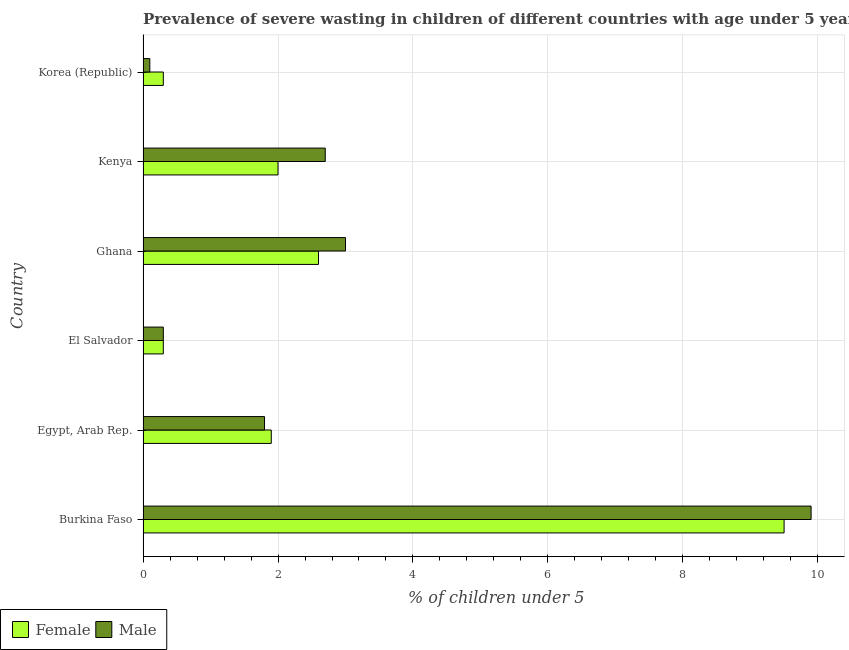How many different coloured bars are there?
Keep it short and to the point. 2. Are the number of bars per tick equal to the number of legend labels?
Your response must be concise. Yes. Are the number of bars on each tick of the Y-axis equal?
Provide a short and direct response. Yes. Across all countries, what is the maximum percentage of undernourished male children?
Give a very brief answer. 9.9. Across all countries, what is the minimum percentage of undernourished female children?
Keep it short and to the point. 0.3. In which country was the percentage of undernourished female children maximum?
Your answer should be compact. Burkina Faso. In which country was the percentage of undernourished male children minimum?
Your answer should be compact. Korea (Republic). What is the total percentage of undernourished male children in the graph?
Ensure brevity in your answer.  17.8. What is the difference between the percentage of undernourished male children in Kenya and the percentage of undernourished female children in Korea (Republic)?
Make the answer very short. 2.4. What is the average percentage of undernourished male children per country?
Your response must be concise. 2.97. What is the difference between the percentage of undernourished female children and percentage of undernourished male children in Kenya?
Ensure brevity in your answer.  -0.7. What is the difference between the highest and the lowest percentage of undernourished female children?
Your response must be concise. 9.2. In how many countries, is the percentage of undernourished female children greater than the average percentage of undernourished female children taken over all countries?
Provide a succinct answer. 1. Is the sum of the percentage of undernourished male children in Egypt, Arab Rep. and Kenya greater than the maximum percentage of undernourished female children across all countries?
Your answer should be compact. No. What does the 2nd bar from the top in Korea (Republic) represents?
Ensure brevity in your answer.  Female. What does the 1st bar from the bottom in Egypt, Arab Rep. represents?
Your answer should be compact. Female. How many bars are there?
Your answer should be very brief. 12. Are all the bars in the graph horizontal?
Provide a short and direct response. Yes. What is the difference between two consecutive major ticks on the X-axis?
Keep it short and to the point. 2. Does the graph contain any zero values?
Give a very brief answer. No. Where does the legend appear in the graph?
Your answer should be very brief. Bottom left. How many legend labels are there?
Make the answer very short. 2. What is the title of the graph?
Offer a very short reply. Prevalence of severe wasting in children of different countries with age under 5 years. What is the label or title of the X-axis?
Your answer should be compact.  % of children under 5. What is the  % of children under 5 of Male in Burkina Faso?
Provide a short and direct response. 9.9. What is the  % of children under 5 in Female in Egypt, Arab Rep.?
Keep it short and to the point. 1.9. What is the  % of children under 5 in Male in Egypt, Arab Rep.?
Ensure brevity in your answer.  1.8. What is the  % of children under 5 of Female in El Salvador?
Provide a succinct answer. 0.3. What is the  % of children under 5 in Male in El Salvador?
Ensure brevity in your answer.  0.3. What is the  % of children under 5 of Female in Ghana?
Make the answer very short. 2.6. What is the  % of children under 5 in Male in Kenya?
Offer a terse response. 2.7. What is the  % of children under 5 in Female in Korea (Republic)?
Your answer should be very brief. 0.3. What is the  % of children under 5 of Male in Korea (Republic)?
Give a very brief answer. 0.1. Across all countries, what is the maximum  % of children under 5 in Male?
Ensure brevity in your answer.  9.9. Across all countries, what is the minimum  % of children under 5 of Female?
Offer a very short reply. 0.3. Across all countries, what is the minimum  % of children under 5 of Male?
Your answer should be compact. 0.1. What is the total  % of children under 5 in Male in the graph?
Offer a terse response. 17.8. What is the difference between the  % of children under 5 in Female in Burkina Faso and that in Egypt, Arab Rep.?
Ensure brevity in your answer.  7.6. What is the difference between the  % of children under 5 in Male in Burkina Faso and that in Egypt, Arab Rep.?
Provide a succinct answer. 8.1. What is the difference between the  % of children under 5 of Male in Burkina Faso and that in El Salvador?
Your response must be concise. 9.6. What is the difference between the  % of children under 5 in Female in Burkina Faso and that in Kenya?
Your answer should be compact. 7.5. What is the difference between the  % of children under 5 of Male in Egypt, Arab Rep. and that in El Salvador?
Provide a short and direct response. 1.5. What is the difference between the  % of children under 5 of Male in Egypt, Arab Rep. and that in Ghana?
Keep it short and to the point. -1.2. What is the difference between the  % of children under 5 of Female in Egypt, Arab Rep. and that in Kenya?
Your answer should be compact. -0.1. What is the difference between the  % of children under 5 in Female in Egypt, Arab Rep. and that in Korea (Republic)?
Your response must be concise. 1.6. What is the difference between the  % of children under 5 in Male in El Salvador and that in Ghana?
Offer a very short reply. -2.7. What is the difference between the  % of children under 5 of Male in El Salvador and that in Korea (Republic)?
Ensure brevity in your answer.  0.2. What is the difference between the  % of children under 5 of Male in Ghana and that in Kenya?
Offer a terse response. 0.3. What is the difference between the  % of children under 5 of Male in Kenya and that in Korea (Republic)?
Give a very brief answer. 2.6. What is the difference between the  % of children under 5 in Female in Burkina Faso and the  % of children under 5 in Male in Egypt, Arab Rep.?
Offer a very short reply. 7.7. What is the difference between the  % of children under 5 of Female in Burkina Faso and the  % of children under 5 of Male in Korea (Republic)?
Offer a terse response. 9.4. What is the difference between the  % of children under 5 in Female in Egypt, Arab Rep. and the  % of children under 5 in Male in Ghana?
Give a very brief answer. -1.1. What is the difference between the  % of children under 5 of Female in Egypt, Arab Rep. and the  % of children under 5 of Male in Kenya?
Your response must be concise. -0.8. What is the average  % of children under 5 in Female per country?
Ensure brevity in your answer.  2.77. What is the average  % of children under 5 of Male per country?
Ensure brevity in your answer.  2.97. What is the difference between the  % of children under 5 in Female and  % of children under 5 in Male in Burkina Faso?
Your answer should be compact. -0.4. What is the difference between the  % of children under 5 of Female and  % of children under 5 of Male in Egypt, Arab Rep.?
Offer a very short reply. 0.1. What is the difference between the  % of children under 5 of Female and  % of children under 5 of Male in El Salvador?
Give a very brief answer. 0. What is the difference between the  % of children under 5 of Female and  % of children under 5 of Male in Ghana?
Provide a short and direct response. -0.4. What is the difference between the  % of children under 5 in Female and  % of children under 5 in Male in Kenya?
Ensure brevity in your answer.  -0.7. What is the ratio of the  % of children under 5 of Female in Burkina Faso to that in El Salvador?
Give a very brief answer. 31.67. What is the ratio of the  % of children under 5 of Female in Burkina Faso to that in Ghana?
Ensure brevity in your answer.  3.65. What is the ratio of the  % of children under 5 of Male in Burkina Faso to that in Ghana?
Your answer should be very brief. 3.3. What is the ratio of the  % of children under 5 in Female in Burkina Faso to that in Kenya?
Offer a very short reply. 4.75. What is the ratio of the  % of children under 5 in Male in Burkina Faso to that in Kenya?
Provide a short and direct response. 3.67. What is the ratio of the  % of children under 5 in Female in Burkina Faso to that in Korea (Republic)?
Provide a succinct answer. 31.67. What is the ratio of the  % of children under 5 of Female in Egypt, Arab Rep. to that in El Salvador?
Keep it short and to the point. 6.33. What is the ratio of the  % of children under 5 in Female in Egypt, Arab Rep. to that in Ghana?
Provide a succinct answer. 0.73. What is the ratio of the  % of children under 5 in Male in Egypt, Arab Rep. to that in Ghana?
Ensure brevity in your answer.  0.6. What is the ratio of the  % of children under 5 in Female in Egypt, Arab Rep. to that in Kenya?
Offer a terse response. 0.95. What is the ratio of the  % of children under 5 in Male in Egypt, Arab Rep. to that in Kenya?
Give a very brief answer. 0.67. What is the ratio of the  % of children under 5 of Female in Egypt, Arab Rep. to that in Korea (Republic)?
Your response must be concise. 6.33. What is the ratio of the  % of children under 5 in Female in El Salvador to that in Ghana?
Offer a very short reply. 0.12. What is the ratio of the  % of children under 5 of Male in El Salvador to that in Ghana?
Offer a terse response. 0.1. What is the ratio of the  % of children under 5 of Female in El Salvador to that in Kenya?
Your answer should be compact. 0.15. What is the ratio of the  % of children under 5 of Female in El Salvador to that in Korea (Republic)?
Your answer should be very brief. 1. What is the ratio of the  % of children under 5 in Male in El Salvador to that in Korea (Republic)?
Offer a terse response. 3. What is the ratio of the  % of children under 5 of Female in Ghana to that in Kenya?
Keep it short and to the point. 1.3. What is the ratio of the  % of children under 5 in Female in Ghana to that in Korea (Republic)?
Offer a very short reply. 8.67. What is the ratio of the  % of children under 5 of Male in Kenya to that in Korea (Republic)?
Your answer should be compact. 27. What is the difference between the highest and the lowest  % of children under 5 of Male?
Ensure brevity in your answer.  9.8. 